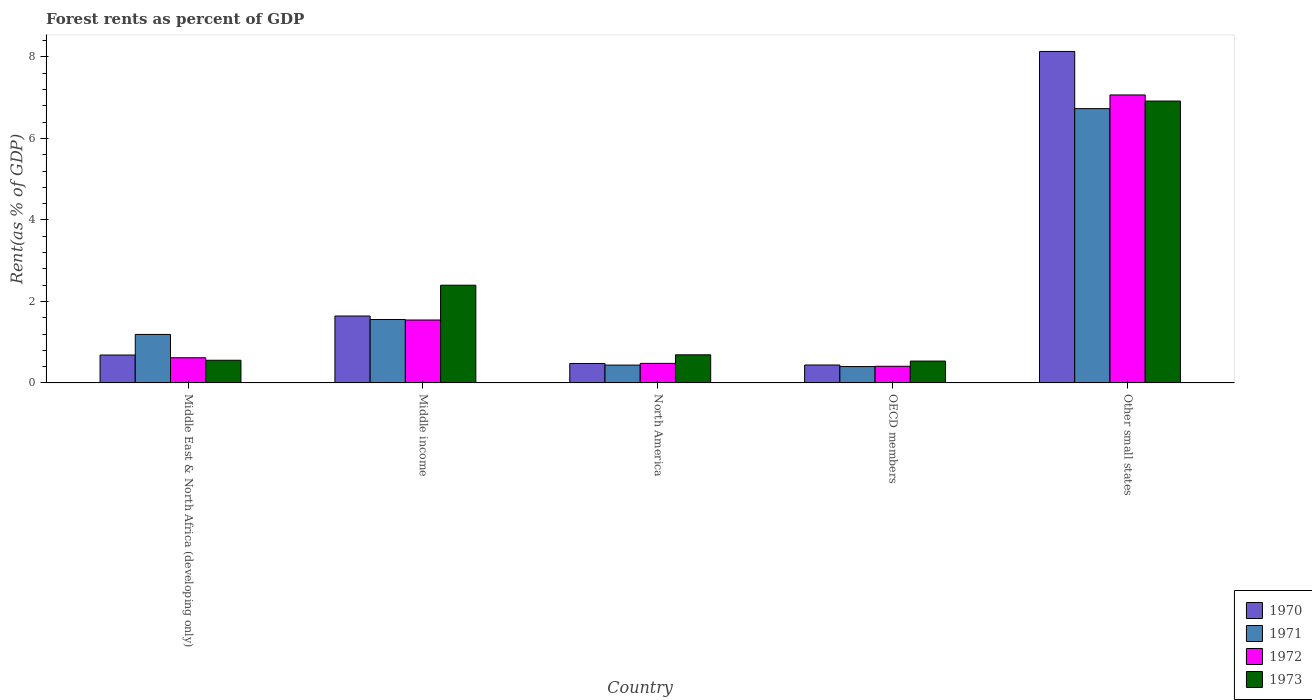How many different coloured bars are there?
Give a very brief answer. 4. How many groups of bars are there?
Offer a terse response. 5. How many bars are there on the 4th tick from the right?
Offer a terse response. 4. What is the label of the 1st group of bars from the left?
Your answer should be compact. Middle East & North Africa (developing only). In how many cases, is the number of bars for a given country not equal to the number of legend labels?
Ensure brevity in your answer.  0. What is the forest rent in 1973 in Middle East & North Africa (developing only)?
Your response must be concise. 0.56. Across all countries, what is the maximum forest rent in 1970?
Give a very brief answer. 8.13. Across all countries, what is the minimum forest rent in 1973?
Provide a succinct answer. 0.54. In which country was the forest rent in 1970 maximum?
Give a very brief answer. Other small states. What is the total forest rent in 1970 in the graph?
Your answer should be compact. 11.38. What is the difference between the forest rent in 1973 in Middle income and that in OECD members?
Make the answer very short. 1.86. What is the difference between the forest rent in 1970 in Middle East & North Africa (developing only) and the forest rent in 1972 in Middle income?
Make the answer very short. -0.86. What is the average forest rent in 1970 per country?
Keep it short and to the point. 2.28. What is the difference between the forest rent of/in 1971 and forest rent of/in 1972 in OECD members?
Give a very brief answer. -0.01. What is the ratio of the forest rent in 1973 in Middle income to that in OECD members?
Your answer should be compact. 4.47. Is the forest rent in 1970 in North America less than that in OECD members?
Provide a short and direct response. No. What is the difference between the highest and the second highest forest rent in 1973?
Offer a very short reply. -1.71. What is the difference between the highest and the lowest forest rent in 1972?
Your response must be concise. 6.66. In how many countries, is the forest rent in 1970 greater than the average forest rent in 1970 taken over all countries?
Ensure brevity in your answer.  1. Is the sum of the forest rent in 1972 in North America and OECD members greater than the maximum forest rent in 1971 across all countries?
Make the answer very short. No. What does the 3rd bar from the left in Middle East & North Africa (developing only) represents?
Offer a very short reply. 1972. Is it the case that in every country, the sum of the forest rent in 1973 and forest rent in 1971 is greater than the forest rent in 1970?
Your answer should be very brief. Yes. Are all the bars in the graph horizontal?
Ensure brevity in your answer.  No. How many countries are there in the graph?
Make the answer very short. 5. What is the difference between two consecutive major ticks on the Y-axis?
Offer a very short reply. 2. Are the values on the major ticks of Y-axis written in scientific E-notation?
Your answer should be very brief. No. Does the graph contain any zero values?
Your answer should be compact. No. Does the graph contain grids?
Provide a short and direct response. No. How many legend labels are there?
Your response must be concise. 4. What is the title of the graph?
Give a very brief answer. Forest rents as percent of GDP. What is the label or title of the X-axis?
Provide a short and direct response. Country. What is the label or title of the Y-axis?
Your response must be concise. Rent(as % of GDP). What is the Rent(as % of GDP) of 1970 in Middle East & North Africa (developing only)?
Your answer should be compact. 0.69. What is the Rent(as % of GDP) in 1971 in Middle East & North Africa (developing only)?
Offer a terse response. 1.19. What is the Rent(as % of GDP) in 1972 in Middle East & North Africa (developing only)?
Keep it short and to the point. 0.62. What is the Rent(as % of GDP) of 1973 in Middle East & North Africa (developing only)?
Ensure brevity in your answer.  0.56. What is the Rent(as % of GDP) of 1970 in Middle income?
Give a very brief answer. 1.64. What is the Rent(as % of GDP) of 1971 in Middle income?
Your answer should be very brief. 1.56. What is the Rent(as % of GDP) in 1972 in Middle income?
Keep it short and to the point. 1.54. What is the Rent(as % of GDP) in 1973 in Middle income?
Your response must be concise. 2.4. What is the Rent(as % of GDP) of 1970 in North America?
Provide a short and direct response. 0.48. What is the Rent(as % of GDP) in 1971 in North America?
Make the answer very short. 0.44. What is the Rent(as % of GDP) of 1972 in North America?
Make the answer very short. 0.48. What is the Rent(as % of GDP) of 1973 in North America?
Provide a succinct answer. 0.69. What is the Rent(as % of GDP) in 1970 in OECD members?
Offer a very short reply. 0.44. What is the Rent(as % of GDP) in 1971 in OECD members?
Offer a very short reply. 0.4. What is the Rent(as % of GDP) in 1972 in OECD members?
Your answer should be very brief. 0.41. What is the Rent(as % of GDP) in 1973 in OECD members?
Keep it short and to the point. 0.54. What is the Rent(as % of GDP) of 1970 in Other small states?
Your answer should be very brief. 8.13. What is the Rent(as % of GDP) in 1971 in Other small states?
Offer a terse response. 6.73. What is the Rent(as % of GDP) of 1972 in Other small states?
Provide a succinct answer. 7.07. What is the Rent(as % of GDP) of 1973 in Other small states?
Make the answer very short. 6.92. Across all countries, what is the maximum Rent(as % of GDP) of 1970?
Your response must be concise. 8.13. Across all countries, what is the maximum Rent(as % of GDP) in 1971?
Offer a terse response. 6.73. Across all countries, what is the maximum Rent(as % of GDP) in 1972?
Make the answer very short. 7.07. Across all countries, what is the maximum Rent(as % of GDP) in 1973?
Your response must be concise. 6.92. Across all countries, what is the minimum Rent(as % of GDP) in 1970?
Keep it short and to the point. 0.44. Across all countries, what is the minimum Rent(as % of GDP) in 1971?
Make the answer very short. 0.4. Across all countries, what is the minimum Rent(as % of GDP) in 1972?
Provide a short and direct response. 0.41. Across all countries, what is the minimum Rent(as % of GDP) in 1973?
Make the answer very short. 0.54. What is the total Rent(as % of GDP) of 1970 in the graph?
Provide a succinct answer. 11.38. What is the total Rent(as % of GDP) in 1971 in the graph?
Keep it short and to the point. 10.32. What is the total Rent(as % of GDP) of 1972 in the graph?
Keep it short and to the point. 10.12. What is the total Rent(as % of GDP) of 1973 in the graph?
Offer a terse response. 11.1. What is the difference between the Rent(as % of GDP) in 1970 in Middle East & North Africa (developing only) and that in Middle income?
Ensure brevity in your answer.  -0.96. What is the difference between the Rent(as % of GDP) of 1971 in Middle East & North Africa (developing only) and that in Middle income?
Your answer should be compact. -0.37. What is the difference between the Rent(as % of GDP) in 1972 in Middle East & North Africa (developing only) and that in Middle income?
Offer a terse response. -0.93. What is the difference between the Rent(as % of GDP) in 1973 in Middle East & North Africa (developing only) and that in Middle income?
Keep it short and to the point. -1.84. What is the difference between the Rent(as % of GDP) in 1970 in Middle East & North Africa (developing only) and that in North America?
Ensure brevity in your answer.  0.21. What is the difference between the Rent(as % of GDP) of 1971 in Middle East & North Africa (developing only) and that in North America?
Provide a short and direct response. 0.75. What is the difference between the Rent(as % of GDP) in 1972 in Middle East & North Africa (developing only) and that in North America?
Give a very brief answer. 0.14. What is the difference between the Rent(as % of GDP) of 1973 in Middle East & North Africa (developing only) and that in North America?
Provide a short and direct response. -0.13. What is the difference between the Rent(as % of GDP) in 1970 in Middle East & North Africa (developing only) and that in OECD members?
Offer a very short reply. 0.25. What is the difference between the Rent(as % of GDP) in 1971 in Middle East & North Africa (developing only) and that in OECD members?
Your answer should be very brief. 0.79. What is the difference between the Rent(as % of GDP) of 1972 in Middle East & North Africa (developing only) and that in OECD members?
Keep it short and to the point. 0.21. What is the difference between the Rent(as % of GDP) of 1973 in Middle East & North Africa (developing only) and that in OECD members?
Keep it short and to the point. 0.02. What is the difference between the Rent(as % of GDP) in 1970 in Middle East & North Africa (developing only) and that in Other small states?
Provide a succinct answer. -7.45. What is the difference between the Rent(as % of GDP) of 1971 in Middle East & North Africa (developing only) and that in Other small states?
Offer a terse response. -5.54. What is the difference between the Rent(as % of GDP) in 1972 in Middle East & North Africa (developing only) and that in Other small states?
Your answer should be compact. -6.45. What is the difference between the Rent(as % of GDP) of 1973 in Middle East & North Africa (developing only) and that in Other small states?
Make the answer very short. -6.36. What is the difference between the Rent(as % of GDP) of 1970 in Middle income and that in North America?
Your answer should be compact. 1.16. What is the difference between the Rent(as % of GDP) in 1971 in Middle income and that in North America?
Provide a short and direct response. 1.12. What is the difference between the Rent(as % of GDP) in 1972 in Middle income and that in North America?
Provide a short and direct response. 1.06. What is the difference between the Rent(as % of GDP) of 1973 in Middle income and that in North America?
Provide a short and direct response. 1.71. What is the difference between the Rent(as % of GDP) in 1970 in Middle income and that in OECD members?
Your answer should be very brief. 1.2. What is the difference between the Rent(as % of GDP) of 1971 in Middle income and that in OECD members?
Keep it short and to the point. 1.15. What is the difference between the Rent(as % of GDP) of 1972 in Middle income and that in OECD members?
Offer a very short reply. 1.14. What is the difference between the Rent(as % of GDP) in 1973 in Middle income and that in OECD members?
Provide a succinct answer. 1.86. What is the difference between the Rent(as % of GDP) of 1970 in Middle income and that in Other small states?
Your response must be concise. -6.49. What is the difference between the Rent(as % of GDP) in 1971 in Middle income and that in Other small states?
Ensure brevity in your answer.  -5.17. What is the difference between the Rent(as % of GDP) of 1972 in Middle income and that in Other small states?
Provide a short and direct response. -5.52. What is the difference between the Rent(as % of GDP) of 1973 in Middle income and that in Other small states?
Your answer should be compact. -4.52. What is the difference between the Rent(as % of GDP) in 1970 in North America and that in OECD members?
Provide a succinct answer. 0.04. What is the difference between the Rent(as % of GDP) of 1971 in North America and that in OECD members?
Provide a short and direct response. 0.04. What is the difference between the Rent(as % of GDP) of 1972 in North America and that in OECD members?
Ensure brevity in your answer.  0.07. What is the difference between the Rent(as % of GDP) of 1973 in North America and that in OECD members?
Make the answer very short. 0.15. What is the difference between the Rent(as % of GDP) of 1970 in North America and that in Other small states?
Your response must be concise. -7.66. What is the difference between the Rent(as % of GDP) in 1971 in North America and that in Other small states?
Keep it short and to the point. -6.29. What is the difference between the Rent(as % of GDP) in 1972 in North America and that in Other small states?
Your answer should be very brief. -6.59. What is the difference between the Rent(as % of GDP) of 1973 in North America and that in Other small states?
Give a very brief answer. -6.23. What is the difference between the Rent(as % of GDP) in 1970 in OECD members and that in Other small states?
Keep it short and to the point. -7.69. What is the difference between the Rent(as % of GDP) in 1971 in OECD members and that in Other small states?
Make the answer very short. -6.33. What is the difference between the Rent(as % of GDP) of 1972 in OECD members and that in Other small states?
Provide a succinct answer. -6.66. What is the difference between the Rent(as % of GDP) of 1973 in OECD members and that in Other small states?
Offer a very short reply. -6.38. What is the difference between the Rent(as % of GDP) in 1970 in Middle East & North Africa (developing only) and the Rent(as % of GDP) in 1971 in Middle income?
Offer a very short reply. -0.87. What is the difference between the Rent(as % of GDP) in 1970 in Middle East & North Africa (developing only) and the Rent(as % of GDP) in 1972 in Middle income?
Give a very brief answer. -0.86. What is the difference between the Rent(as % of GDP) of 1970 in Middle East & North Africa (developing only) and the Rent(as % of GDP) of 1973 in Middle income?
Make the answer very short. -1.71. What is the difference between the Rent(as % of GDP) in 1971 in Middle East & North Africa (developing only) and the Rent(as % of GDP) in 1972 in Middle income?
Your answer should be very brief. -0.35. What is the difference between the Rent(as % of GDP) in 1971 in Middle East & North Africa (developing only) and the Rent(as % of GDP) in 1973 in Middle income?
Ensure brevity in your answer.  -1.21. What is the difference between the Rent(as % of GDP) in 1972 in Middle East & North Africa (developing only) and the Rent(as % of GDP) in 1973 in Middle income?
Offer a very short reply. -1.78. What is the difference between the Rent(as % of GDP) in 1970 in Middle East & North Africa (developing only) and the Rent(as % of GDP) in 1971 in North America?
Offer a very short reply. 0.25. What is the difference between the Rent(as % of GDP) of 1970 in Middle East & North Africa (developing only) and the Rent(as % of GDP) of 1972 in North America?
Your answer should be compact. 0.21. What is the difference between the Rent(as % of GDP) of 1970 in Middle East & North Africa (developing only) and the Rent(as % of GDP) of 1973 in North America?
Your answer should be compact. -0.01. What is the difference between the Rent(as % of GDP) in 1971 in Middle East & North Africa (developing only) and the Rent(as % of GDP) in 1972 in North America?
Provide a succinct answer. 0.71. What is the difference between the Rent(as % of GDP) of 1972 in Middle East & North Africa (developing only) and the Rent(as % of GDP) of 1973 in North America?
Provide a short and direct response. -0.07. What is the difference between the Rent(as % of GDP) in 1970 in Middle East & North Africa (developing only) and the Rent(as % of GDP) in 1971 in OECD members?
Make the answer very short. 0.28. What is the difference between the Rent(as % of GDP) of 1970 in Middle East & North Africa (developing only) and the Rent(as % of GDP) of 1972 in OECD members?
Offer a very short reply. 0.28. What is the difference between the Rent(as % of GDP) of 1970 in Middle East & North Africa (developing only) and the Rent(as % of GDP) of 1973 in OECD members?
Make the answer very short. 0.15. What is the difference between the Rent(as % of GDP) in 1971 in Middle East & North Africa (developing only) and the Rent(as % of GDP) in 1972 in OECD members?
Your answer should be very brief. 0.78. What is the difference between the Rent(as % of GDP) of 1971 in Middle East & North Africa (developing only) and the Rent(as % of GDP) of 1973 in OECD members?
Give a very brief answer. 0.65. What is the difference between the Rent(as % of GDP) in 1972 in Middle East & North Africa (developing only) and the Rent(as % of GDP) in 1973 in OECD members?
Give a very brief answer. 0.08. What is the difference between the Rent(as % of GDP) in 1970 in Middle East & North Africa (developing only) and the Rent(as % of GDP) in 1971 in Other small states?
Your response must be concise. -6.05. What is the difference between the Rent(as % of GDP) in 1970 in Middle East & North Africa (developing only) and the Rent(as % of GDP) in 1972 in Other small states?
Provide a succinct answer. -6.38. What is the difference between the Rent(as % of GDP) in 1970 in Middle East & North Africa (developing only) and the Rent(as % of GDP) in 1973 in Other small states?
Provide a short and direct response. -6.23. What is the difference between the Rent(as % of GDP) of 1971 in Middle East & North Africa (developing only) and the Rent(as % of GDP) of 1972 in Other small states?
Your answer should be compact. -5.88. What is the difference between the Rent(as % of GDP) of 1971 in Middle East & North Africa (developing only) and the Rent(as % of GDP) of 1973 in Other small states?
Your answer should be very brief. -5.73. What is the difference between the Rent(as % of GDP) of 1972 in Middle East & North Africa (developing only) and the Rent(as % of GDP) of 1973 in Other small states?
Offer a terse response. -6.3. What is the difference between the Rent(as % of GDP) in 1970 in Middle income and the Rent(as % of GDP) in 1971 in North America?
Provide a succinct answer. 1.2. What is the difference between the Rent(as % of GDP) in 1970 in Middle income and the Rent(as % of GDP) in 1972 in North America?
Offer a very short reply. 1.16. What is the difference between the Rent(as % of GDP) in 1970 in Middle income and the Rent(as % of GDP) in 1973 in North America?
Give a very brief answer. 0.95. What is the difference between the Rent(as % of GDP) in 1971 in Middle income and the Rent(as % of GDP) in 1973 in North America?
Offer a terse response. 0.87. What is the difference between the Rent(as % of GDP) in 1972 in Middle income and the Rent(as % of GDP) in 1973 in North America?
Give a very brief answer. 0.85. What is the difference between the Rent(as % of GDP) in 1970 in Middle income and the Rent(as % of GDP) in 1971 in OECD members?
Give a very brief answer. 1.24. What is the difference between the Rent(as % of GDP) of 1970 in Middle income and the Rent(as % of GDP) of 1972 in OECD members?
Keep it short and to the point. 1.23. What is the difference between the Rent(as % of GDP) of 1970 in Middle income and the Rent(as % of GDP) of 1973 in OECD members?
Offer a terse response. 1.11. What is the difference between the Rent(as % of GDP) of 1971 in Middle income and the Rent(as % of GDP) of 1972 in OECD members?
Your answer should be very brief. 1.15. What is the difference between the Rent(as % of GDP) of 1971 in Middle income and the Rent(as % of GDP) of 1973 in OECD members?
Keep it short and to the point. 1.02. What is the difference between the Rent(as % of GDP) in 1972 in Middle income and the Rent(as % of GDP) in 1973 in OECD members?
Provide a succinct answer. 1.01. What is the difference between the Rent(as % of GDP) of 1970 in Middle income and the Rent(as % of GDP) of 1971 in Other small states?
Offer a very short reply. -5.09. What is the difference between the Rent(as % of GDP) of 1970 in Middle income and the Rent(as % of GDP) of 1972 in Other small states?
Make the answer very short. -5.42. What is the difference between the Rent(as % of GDP) of 1970 in Middle income and the Rent(as % of GDP) of 1973 in Other small states?
Make the answer very short. -5.27. What is the difference between the Rent(as % of GDP) of 1971 in Middle income and the Rent(as % of GDP) of 1972 in Other small states?
Give a very brief answer. -5.51. What is the difference between the Rent(as % of GDP) in 1971 in Middle income and the Rent(as % of GDP) in 1973 in Other small states?
Your answer should be very brief. -5.36. What is the difference between the Rent(as % of GDP) in 1972 in Middle income and the Rent(as % of GDP) in 1973 in Other small states?
Your answer should be very brief. -5.37. What is the difference between the Rent(as % of GDP) in 1970 in North America and the Rent(as % of GDP) in 1971 in OECD members?
Keep it short and to the point. 0.08. What is the difference between the Rent(as % of GDP) in 1970 in North America and the Rent(as % of GDP) in 1972 in OECD members?
Your response must be concise. 0.07. What is the difference between the Rent(as % of GDP) in 1970 in North America and the Rent(as % of GDP) in 1973 in OECD members?
Your answer should be compact. -0.06. What is the difference between the Rent(as % of GDP) in 1971 in North America and the Rent(as % of GDP) in 1972 in OECD members?
Provide a succinct answer. 0.03. What is the difference between the Rent(as % of GDP) of 1971 in North America and the Rent(as % of GDP) of 1973 in OECD members?
Your answer should be very brief. -0.1. What is the difference between the Rent(as % of GDP) of 1972 in North America and the Rent(as % of GDP) of 1973 in OECD members?
Your answer should be very brief. -0.06. What is the difference between the Rent(as % of GDP) in 1970 in North America and the Rent(as % of GDP) in 1971 in Other small states?
Give a very brief answer. -6.25. What is the difference between the Rent(as % of GDP) in 1970 in North America and the Rent(as % of GDP) in 1972 in Other small states?
Keep it short and to the point. -6.59. What is the difference between the Rent(as % of GDP) of 1970 in North America and the Rent(as % of GDP) of 1973 in Other small states?
Make the answer very short. -6.44. What is the difference between the Rent(as % of GDP) in 1971 in North America and the Rent(as % of GDP) in 1972 in Other small states?
Offer a terse response. -6.63. What is the difference between the Rent(as % of GDP) in 1971 in North America and the Rent(as % of GDP) in 1973 in Other small states?
Provide a short and direct response. -6.48. What is the difference between the Rent(as % of GDP) in 1972 in North America and the Rent(as % of GDP) in 1973 in Other small states?
Ensure brevity in your answer.  -6.44. What is the difference between the Rent(as % of GDP) in 1970 in OECD members and the Rent(as % of GDP) in 1971 in Other small states?
Provide a short and direct response. -6.29. What is the difference between the Rent(as % of GDP) in 1970 in OECD members and the Rent(as % of GDP) in 1972 in Other small states?
Provide a short and direct response. -6.63. What is the difference between the Rent(as % of GDP) in 1970 in OECD members and the Rent(as % of GDP) in 1973 in Other small states?
Keep it short and to the point. -6.48. What is the difference between the Rent(as % of GDP) in 1971 in OECD members and the Rent(as % of GDP) in 1972 in Other small states?
Your answer should be very brief. -6.67. What is the difference between the Rent(as % of GDP) in 1971 in OECD members and the Rent(as % of GDP) in 1973 in Other small states?
Offer a terse response. -6.52. What is the difference between the Rent(as % of GDP) in 1972 in OECD members and the Rent(as % of GDP) in 1973 in Other small states?
Your answer should be very brief. -6.51. What is the average Rent(as % of GDP) in 1970 per country?
Your response must be concise. 2.28. What is the average Rent(as % of GDP) of 1971 per country?
Your response must be concise. 2.06. What is the average Rent(as % of GDP) of 1972 per country?
Your answer should be very brief. 2.02. What is the average Rent(as % of GDP) in 1973 per country?
Your response must be concise. 2.22. What is the difference between the Rent(as % of GDP) of 1970 and Rent(as % of GDP) of 1971 in Middle East & North Africa (developing only)?
Ensure brevity in your answer.  -0.51. What is the difference between the Rent(as % of GDP) of 1970 and Rent(as % of GDP) of 1972 in Middle East & North Africa (developing only)?
Ensure brevity in your answer.  0.07. What is the difference between the Rent(as % of GDP) in 1970 and Rent(as % of GDP) in 1973 in Middle East & North Africa (developing only)?
Make the answer very short. 0.13. What is the difference between the Rent(as % of GDP) of 1971 and Rent(as % of GDP) of 1972 in Middle East & North Africa (developing only)?
Keep it short and to the point. 0.57. What is the difference between the Rent(as % of GDP) in 1971 and Rent(as % of GDP) in 1973 in Middle East & North Africa (developing only)?
Give a very brief answer. 0.63. What is the difference between the Rent(as % of GDP) of 1972 and Rent(as % of GDP) of 1973 in Middle East & North Africa (developing only)?
Give a very brief answer. 0.06. What is the difference between the Rent(as % of GDP) of 1970 and Rent(as % of GDP) of 1971 in Middle income?
Your response must be concise. 0.09. What is the difference between the Rent(as % of GDP) in 1970 and Rent(as % of GDP) in 1972 in Middle income?
Your answer should be compact. 0.1. What is the difference between the Rent(as % of GDP) of 1970 and Rent(as % of GDP) of 1973 in Middle income?
Give a very brief answer. -0.76. What is the difference between the Rent(as % of GDP) of 1971 and Rent(as % of GDP) of 1972 in Middle income?
Ensure brevity in your answer.  0.01. What is the difference between the Rent(as % of GDP) in 1971 and Rent(as % of GDP) in 1973 in Middle income?
Provide a succinct answer. -0.84. What is the difference between the Rent(as % of GDP) in 1972 and Rent(as % of GDP) in 1973 in Middle income?
Keep it short and to the point. -0.85. What is the difference between the Rent(as % of GDP) of 1970 and Rent(as % of GDP) of 1971 in North America?
Provide a succinct answer. 0.04. What is the difference between the Rent(as % of GDP) of 1970 and Rent(as % of GDP) of 1972 in North America?
Offer a terse response. -0. What is the difference between the Rent(as % of GDP) in 1970 and Rent(as % of GDP) in 1973 in North America?
Give a very brief answer. -0.21. What is the difference between the Rent(as % of GDP) in 1971 and Rent(as % of GDP) in 1972 in North America?
Your answer should be very brief. -0.04. What is the difference between the Rent(as % of GDP) in 1971 and Rent(as % of GDP) in 1973 in North America?
Provide a succinct answer. -0.25. What is the difference between the Rent(as % of GDP) in 1972 and Rent(as % of GDP) in 1973 in North America?
Offer a terse response. -0.21. What is the difference between the Rent(as % of GDP) of 1970 and Rent(as % of GDP) of 1971 in OECD members?
Your answer should be compact. 0.04. What is the difference between the Rent(as % of GDP) of 1970 and Rent(as % of GDP) of 1972 in OECD members?
Give a very brief answer. 0.03. What is the difference between the Rent(as % of GDP) of 1970 and Rent(as % of GDP) of 1973 in OECD members?
Provide a succinct answer. -0.1. What is the difference between the Rent(as % of GDP) in 1971 and Rent(as % of GDP) in 1972 in OECD members?
Give a very brief answer. -0.01. What is the difference between the Rent(as % of GDP) of 1971 and Rent(as % of GDP) of 1973 in OECD members?
Provide a short and direct response. -0.14. What is the difference between the Rent(as % of GDP) in 1972 and Rent(as % of GDP) in 1973 in OECD members?
Your answer should be very brief. -0.13. What is the difference between the Rent(as % of GDP) in 1970 and Rent(as % of GDP) in 1971 in Other small states?
Give a very brief answer. 1.4. What is the difference between the Rent(as % of GDP) of 1970 and Rent(as % of GDP) of 1972 in Other small states?
Your answer should be compact. 1.07. What is the difference between the Rent(as % of GDP) in 1970 and Rent(as % of GDP) in 1973 in Other small states?
Provide a short and direct response. 1.22. What is the difference between the Rent(as % of GDP) in 1971 and Rent(as % of GDP) in 1972 in Other small states?
Provide a short and direct response. -0.34. What is the difference between the Rent(as % of GDP) of 1971 and Rent(as % of GDP) of 1973 in Other small states?
Give a very brief answer. -0.19. What is the difference between the Rent(as % of GDP) in 1972 and Rent(as % of GDP) in 1973 in Other small states?
Provide a short and direct response. 0.15. What is the ratio of the Rent(as % of GDP) in 1970 in Middle East & North Africa (developing only) to that in Middle income?
Offer a terse response. 0.42. What is the ratio of the Rent(as % of GDP) of 1971 in Middle East & North Africa (developing only) to that in Middle income?
Give a very brief answer. 0.76. What is the ratio of the Rent(as % of GDP) in 1972 in Middle East & North Africa (developing only) to that in Middle income?
Provide a short and direct response. 0.4. What is the ratio of the Rent(as % of GDP) of 1973 in Middle East & North Africa (developing only) to that in Middle income?
Your answer should be very brief. 0.23. What is the ratio of the Rent(as % of GDP) of 1970 in Middle East & North Africa (developing only) to that in North America?
Your answer should be compact. 1.43. What is the ratio of the Rent(as % of GDP) in 1971 in Middle East & North Africa (developing only) to that in North America?
Your response must be concise. 2.72. What is the ratio of the Rent(as % of GDP) in 1972 in Middle East & North Africa (developing only) to that in North America?
Ensure brevity in your answer.  1.29. What is the ratio of the Rent(as % of GDP) in 1973 in Middle East & North Africa (developing only) to that in North America?
Provide a short and direct response. 0.81. What is the ratio of the Rent(as % of GDP) in 1970 in Middle East & North Africa (developing only) to that in OECD members?
Your response must be concise. 1.56. What is the ratio of the Rent(as % of GDP) in 1971 in Middle East & North Africa (developing only) to that in OECD members?
Your answer should be compact. 2.96. What is the ratio of the Rent(as % of GDP) in 1972 in Middle East & North Africa (developing only) to that in OECD members?
Provide a succinct answer. 1.51. What is the ratio of the Rent(as % of GDP) in 1973 in Middle East & North Africa (developing only) to that in OECD members?
Your answer should be compact. 1.04. What is the ratio of the Rent(as % of GDP) of 1970 in Middle East & North Africa (developing only) to that in Other small states?
Offer a very short reply. 0.08. What is the ratio of the Rent(as % of GDP) in 1971 in Middle East & North Africa (developing only) to that in Other small states?
Your answer should be very brief. 0.18. What is the ratio of the Rent(as % of GDP) of 1972 in Middle East & North Africa (developing only) to that in Other small states?
Your answer should be very brief. 0.09. What is the ratio of the Rent(as % of GDP) in 1973 in Middle East & North Africa (developing only) to that in Other small states?
Offer a very short reply. 0.08. What is the ratio of the Rent(as % of GDP) in 1970 in Middle income to that in North America?
Your answer should be compact. 3.44. What is the ratio of the Rent(as % of GDP) in 1971 in Middle income to that in North America?
Provide a short and direct response. 3.55. What is the ratio of the Rent(as % of GDP) of 1972 in Middle income to that in North America?
Offer a very short reply. 3.22. What is the ratio of the Rent(as % of GDP) of 1973 in Middle income to that in North America?
Keep it short and to the point. 3.47. What is the ratio of the Rent(as % of GDP) in 1970 in Middle income to that in OECD members?
Your answer should be very brief. 3.73. What is the ratio of the Rent(as % of GDP) in 1971 in Middle income to that in OECD members?
Provide a short and direct response. 3.88. What is the ratio of the Rent(as % of GDP) of 1972 in Middle income to that in OECD members?
Provide a succinct answer. 3.78. What is the ratio of the Rent(as % of GDP) in 1973 in Middle income to that in OECD members?
Your answer should be compact. 4.47. What is the ratio of the Rent(as % of GDP) in 1970 in Middle income to that in Other small states?
Your answer should be very brief. 0.2. What is the ratio of the Rent(as % of GDP) of 1971 in Middle income to that in Other small states?
Your response must be concise. 0.23. What is the ratio of the Rent(as % of GDP) in 1972 in Middle income to that in Other small states?
Offer a terse response. 0.22. What is the ratio of the Rent(as % of GDP) in 1973 in Middle income to that in Other small states?
Offer a very short reply. 0.35. What is the ratio of the Rent(as % of GDP) of 1970 in North America to that in OECD members?
Offer a very short reply. 1.09. What is the ratio of the Rent(as % of GDP) in 1972 in North America to that in OECD members?
Provide a succinct answer. 1.17. What is the ratio of the Rent(as % of GDP) of 1973 in North America to that in OECD members?
Your answer should be compact. 1.29. What is the ratio of the Rent(as % of GDP) in 1970 in North America to that in Other small states?
Provide a succinct answer. 0.06. What is the ratio of the Rent(as % of GDP) in 1971 in North America to that in Other small states?
Your response must be concise. 0.07. What is the ratio of the Rent(as % of GDP) of 1972 in North America to that in Other small states?
Keep it short and to the point. 0.07. What is the ratio of the Rent(as % of GDP) of 1973 in North America to that in Other small states?
Provide a short and direct response. 0.1. What is the ratio of the Rent(as % of GDP) of 1970 in OECD members to that in Other small states?
Keep it short and to the point. 0.05. What is the ratio of the Rent(as % of GDP) in 1971 in OECD members to that in Other small states?
Provide a succinct answer. 0.06. What is the ratio of the Rent(as % of GDP) of 1972 in OECD members to that in Other small states?
Offer a terse response. 0.06. What is the ratio of the Rent(as % of GDP) of 1973 in OECD members to that in Other small states?
Offer a terse response. 0.08. What is the difference between the highest and the second highest Rent(as % of GDP) of 1970?
Give a very brief answer. 6.49. What is the difference between the highest and the second highest Rent(as % of GDP) of 1971?
Ensure brevity in your answer.  5.17. What is the difference between the highest and the second highest Rent(as % of GDP) in 1972?
Provide a short and direct response. 5.52. What is the difference between the highest and the second highest Rent(as % of GDP) in 1973?
Your response must be concise. 4.52. What is the difference between the highest and the lowest Rent(as % of GDP) in 1970?
Offer a terse response. 7.69. What is the difference between the highest and the lowest Rent(as % of GDP) in 1971?
Offer a terse response. 6.33. What is the difference between the highest and the lowest Rent(as % of GDP) of 1972?
Give a very brief answer. 6.66. What is the difference between the highest and the lowest Rent(as % of GDP) of 1973?
Offer a terse response. 6.38. 